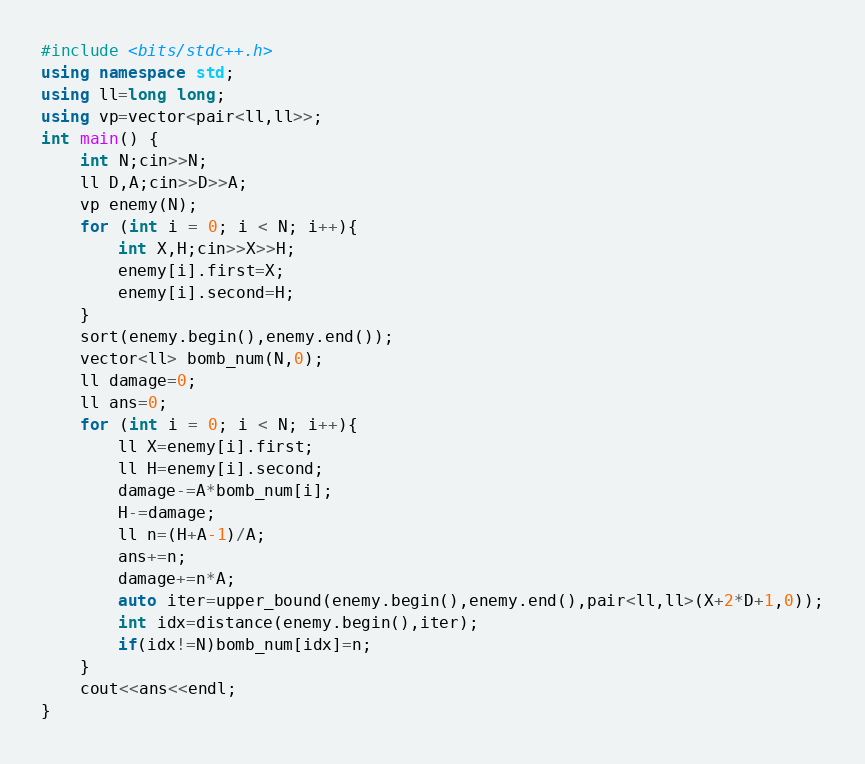Convert code to text. <code><loc_0><loc_0><loc_500><loc_500><_C++_>#include <bits/stdc++.h>
using namespace std;
using ll=long long;
using vp=vector<pair<ll,ll>>;
int main() {
    int N;cin>>N;
    ll D,A;cin>>D>>A;
    vp enemy(N);
    for (int i = 0; i < N; i++){
        int X,H;cin>>X>>H;
        enemy[i].first=X;
        enemy[i].second=H;
    }
    sort(enemy.begin(),enemy.end());
    vector<ll> bomb_num(N,0);
    ll damage=0;
    ll ans=0;
    for (int i = 0; i < N; i++){
        ll X=enemy[i].first;
        ll H=enemy[i].second;
        damage-=A*bomb_num[i];
        H-=damage;
        ll n=(H+A-1)/A;
        ans+=n;
        damage+=n*A;
        auto iter=upper_bound(enemy.begin(),enemy.end(),pair<ll,ll>(X+2*D+1,0));
        int idx=distance(enemy.begin(),iter);
        if(idx!=N)bomb_num[idx]=n;
    }
    cout<<ans<<endl;
}</code> 